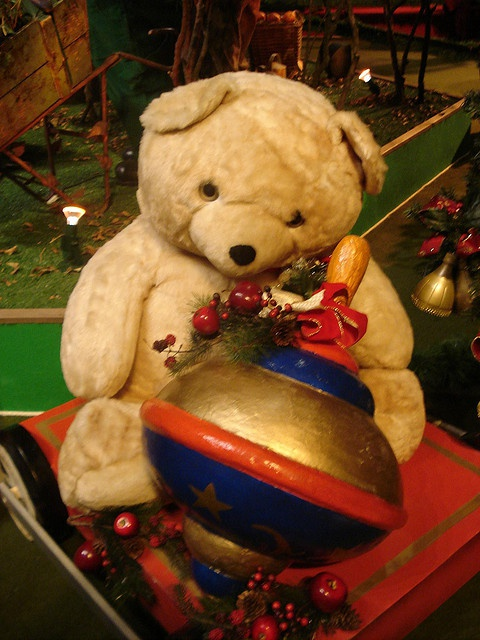Describe the objects in this image and their specific colors. I can see a teddy bear in black, tan, olive, and orange tones in this image. 